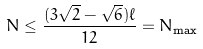<formula> <loc_0><loc_0><loc_500><loc_500>N \leq \frac { ( 3 \sqrt { 2 } - \sqrt { 6 } ) \ell } { 1 2 } = N _ { \max }</formula> 